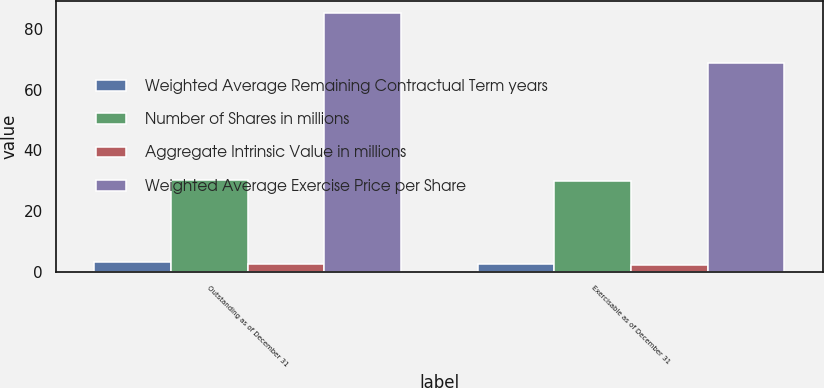Convert chart. <chart><loc_0><loc_0><loc_500><loc_500><stacked_bar_chart><ecel><fcel>Outstanding as of December 31<fcel>Exercisable as of December 31<nl><fcel>Weighted Average Remaining Contractual Term years<fcel>3.2<fcel>2.5<nl><fcel>Number of Shares in millions<fcel>30.35<fcel>29.97<nl><fcel>Aggregate Intrinsic Value in millions<fcel>2.4<fcel>2.2<nl><fcel>Weighted Average Exercise Price per Share<fcel>85.2<fcel>69<nl></chart> 